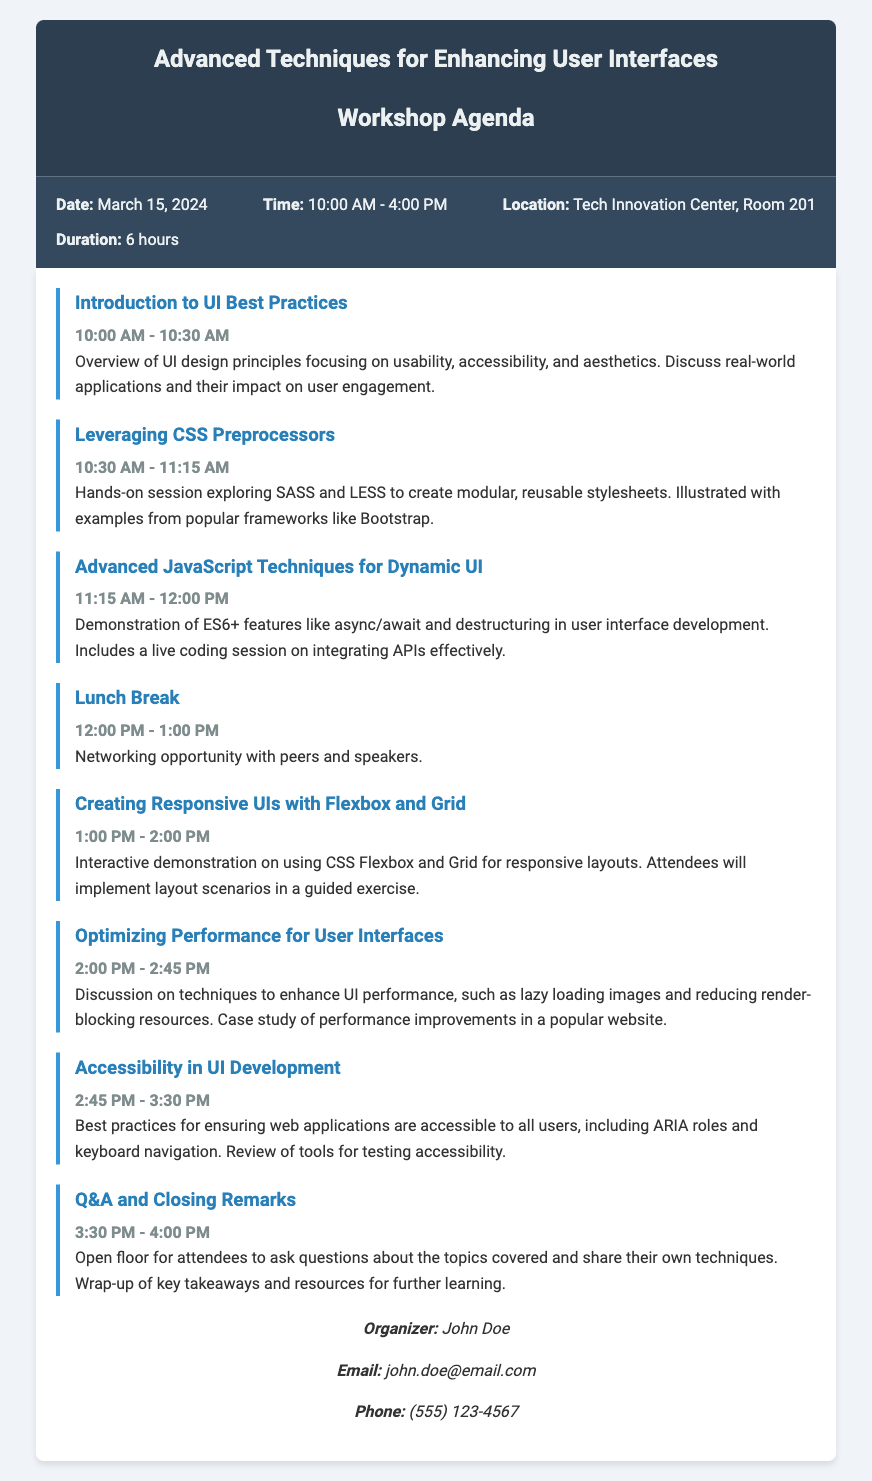What is the date of the workshop? The date of the workshop is specified in the document under workshop info.
Answer: March 15, 2024 What time does the workshop start? The start time of the workshop is listed in the document under workshop info.
Answer: 10:00 AM How long is the lunch break? The duration of the lunch break is mentioned in the agenda.
Answer: 1 hour What is the title of the first agenda item? The title of the first agenda item can be found in the agenda section.
Answer: Introduction to UI Best Practices Who is the organizer of the workshop? The name of the organizer is listed in the contact information section.
Answer: John Doe How many hours does the workshop last? The total duration of the workshop is stated in the workshop info section.
Answer: 6 hours What type of techniques will be explored in the session on "Optimizing Performance for User Interfaces"? The session specifically discusses techniques to enhance UI performance, which is mentioned in the agenda.
Answer: Techniques to enhance UI performance What is the main focus of the "Accessibility in UI Development" session? The main focus of the session is detailed in the agenda, which outlines best practices for accessibility.
Answer: Ensuring web applications are accessible to all users What can attendees expect during the "Q&A and Closing Remarks" segment? The description of this segment in the agenda indicates that it will involve an open floor for questions.
Answer: Open floor for attendees to ask questions 